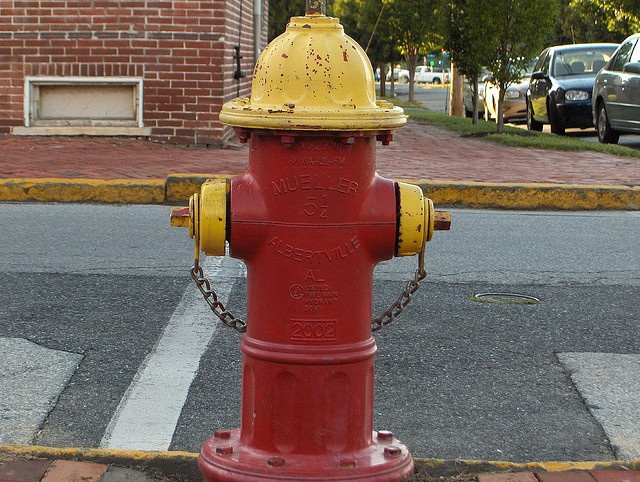Describe the objects in this image and their specific colors. I can see fire hydrant in darkgray, maroon, brown, and tan tones, car in darkgray, black, gray, and white tones, car in darkgray, gray, black, and white tones, car in darkgray, ivory, and gray tones, and truck in darkgray, lightgray, gray, and beige tones in this image. 